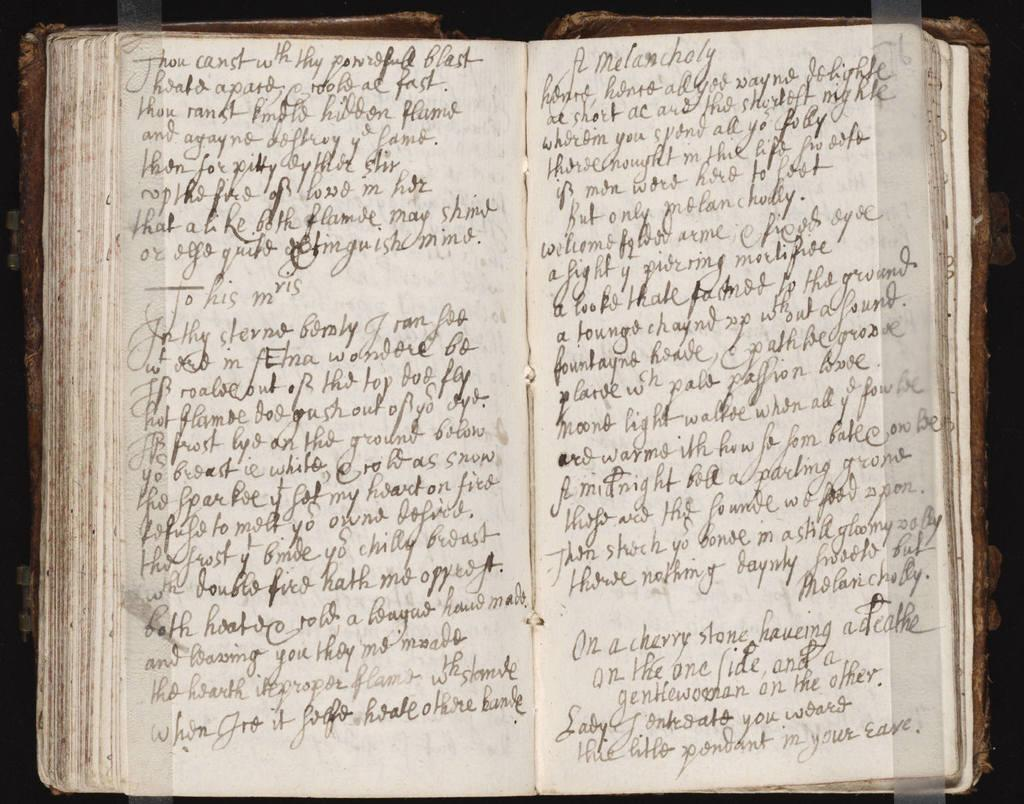<image>
Render a clear and concise summary of the photo. A handwritten poetry collection compares life and death to a cherry stone and a gentle woman. 